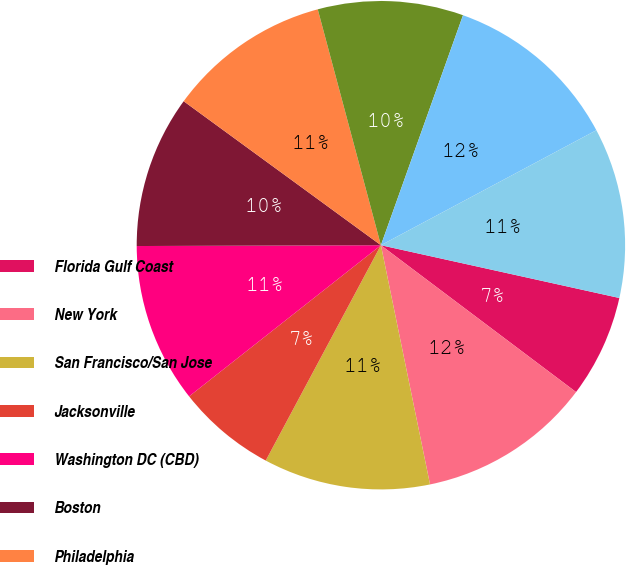Convert chart. <chart><loc_0><loc_0><loc_500><loc_500><pie_chart><fcel>Florida Gulf Coast<fcel>New York<fcel>San Francisco/San Jose<fcel>Jacksonville<fcel>Washington DC (CBD)<fcel>Boston<fcel>Philadelphia<fcel>Chicago<fcel>Los Angeles<fcel>Seattle<nl><fcel>6.8%<fcel>11.51%<fcel>11.04%<fcel>6.56%<fcel>10.57%<fcel>10.09%<fcel>10.8%<fcel>9.62%<fcel>11.74%<fcel>11.27%<nl></chart> 